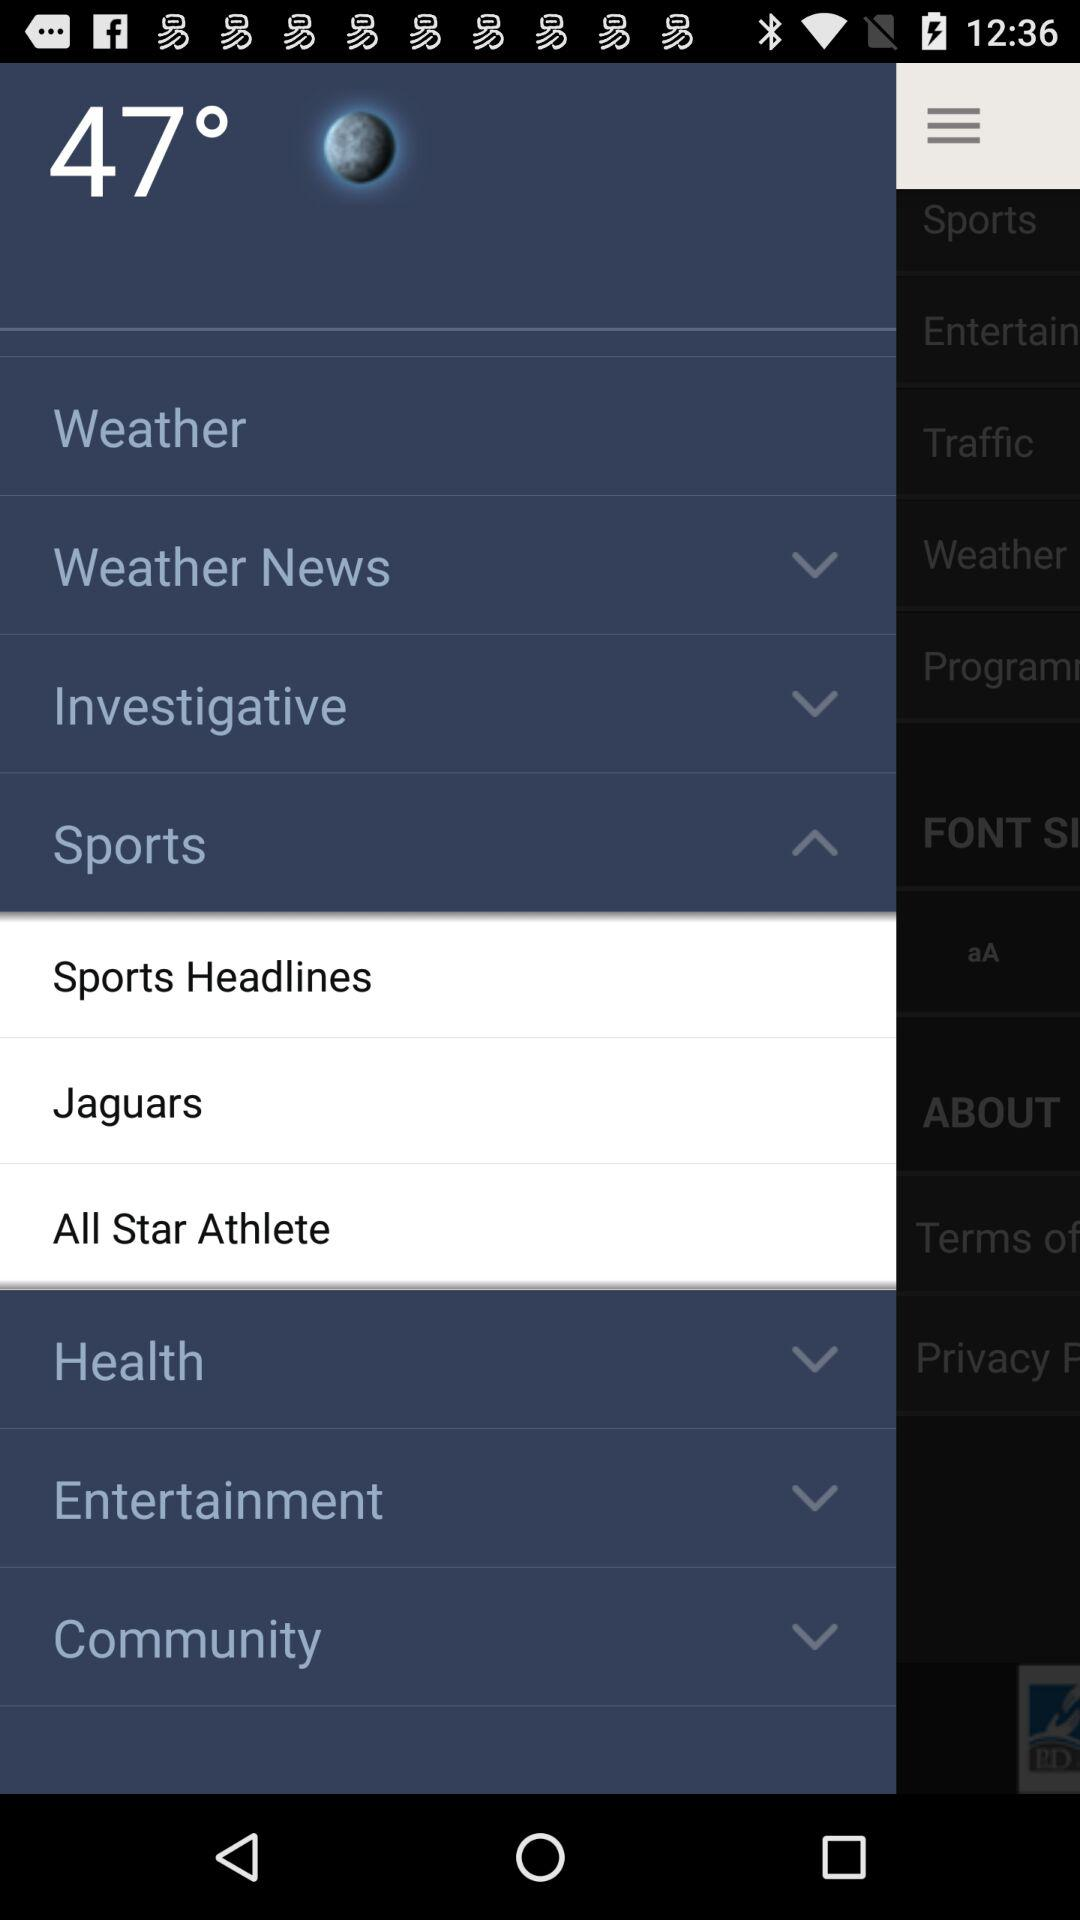Which temperature scale is being used?
When the provided information is insufficient, respond with <no answer>. <no answer> 